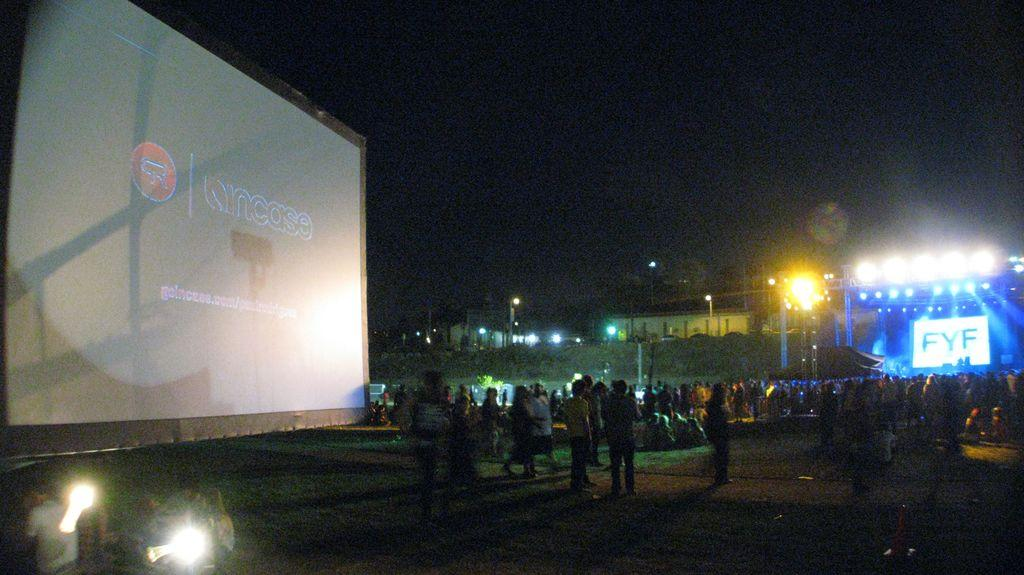How many people are in the image? There is a group of people in the image, but the exact number is not specified. What are the people in the image doing? Some people are standing, while others are sitting on the ground. What objects are present in the image that might be used for displaying information? There are screens present in the image. What can be seen in the image that might provide illumination? Lights are visible in the image. What type of structures are present in the image that might be used for support or stability? Poles are present in the image. What is the color of the background in the image? The background of the image is dark. Can you see a hole in the ground that the people are using as a dance floor in the image? There is no mention of a hole in the ground or any dancing in the image. --- Facts: 1. There is a car in the image. 2. The car is red. 3. The car has four wheels. 4. There is a person in the car. 5. The person is wearing a hat. Absurd Topics: parrot, sandcastle, volcano Conversation: What is the main subject of the image? The main subject of the image is a car. What color is the car? The car is red. How many wheels does the car have? The car has four wheels. Is there anyone inside the car? Yes, there is a person in the car. What is the person wearing? The person is wearing a hat. Reasoning: Let's think step by step in order to produce the conversation. We start by identifying the main subject of the image, which is the car. Then, we describe specific features of the car, such as its color and the number of wheels. Next, we acknowledge the presence of a person inside the car and describe what they are wearing. Each question is designed to elicit a specific detail about the image that is known from the provided facts. Absurd Question/Answer: Can you see a parrot sitting on the roof of the car in the image? There is no mention of a parrot or any animal on the car in the image. Is there a sandcastle being built next to the car in the image? There is no mention of a sandcastle or any construction activity in the image. 